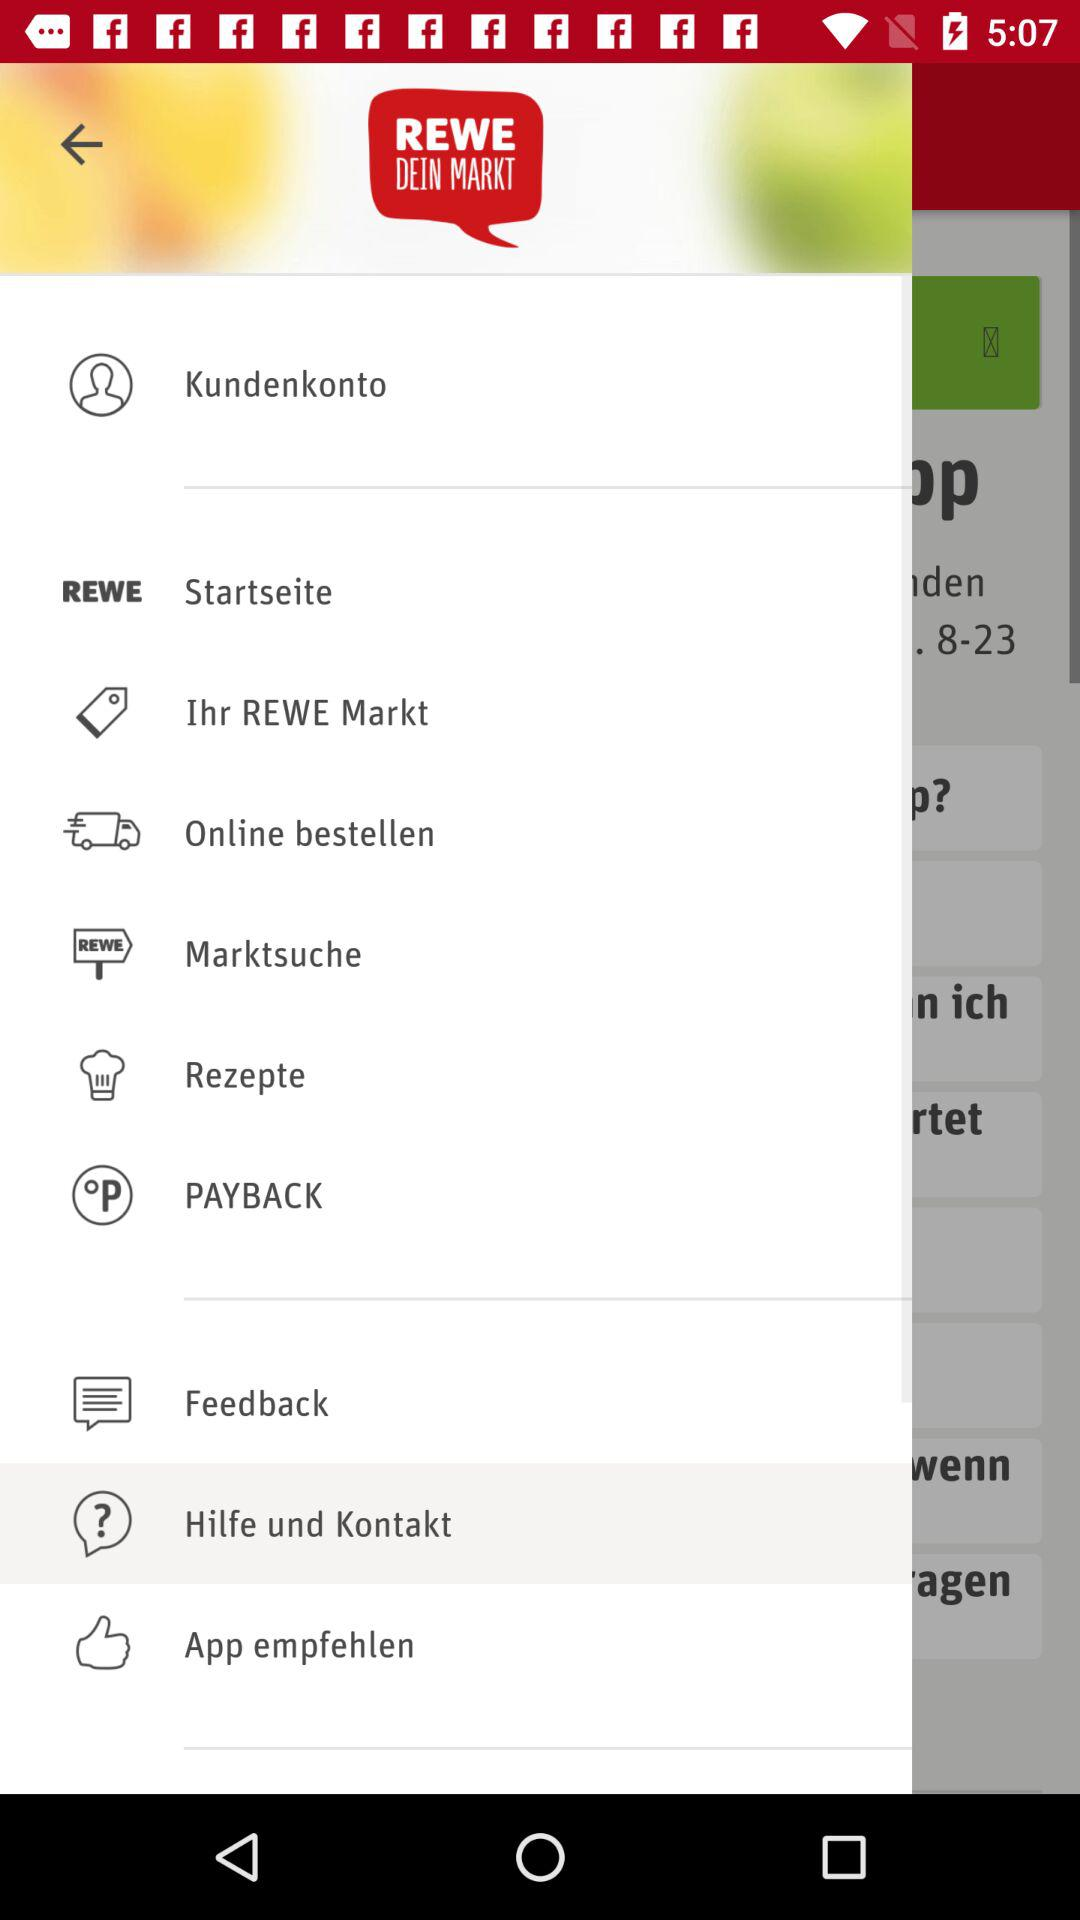What is the profile name? The profile name is Kundenkonto. 